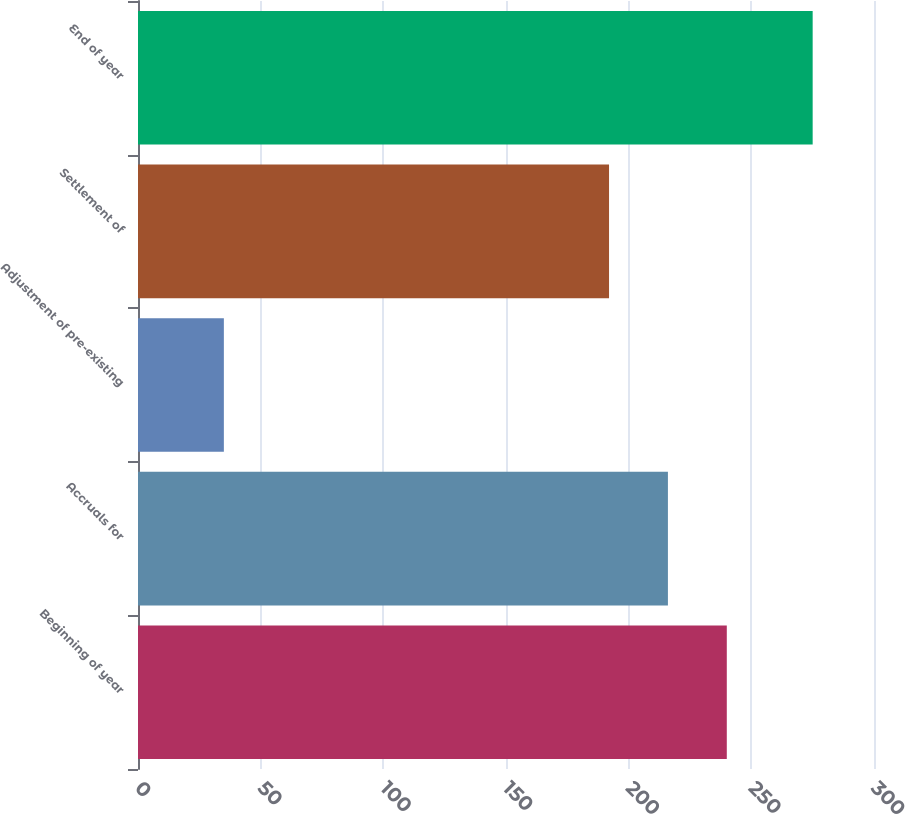Convert chart. <chart><loc_0><loc_0><loc_500><loc_500><bar_chart><fcel>Beginning of year<fcel>Accruals for<fcel>Adjustment of pre-existing<fcel>Settlement of<fcel>End of year<nl><fcel>240<fcel>216<fcel>35<fcel>192<fcel>275<nl></chart> 